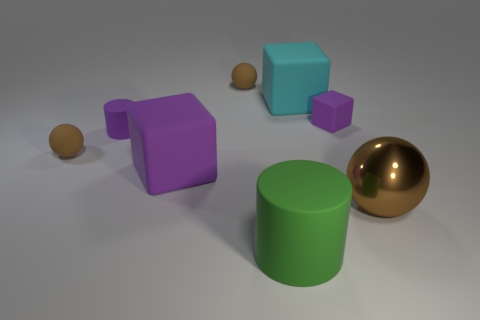Add 1 green things. How many objects exist? 9 Subtract all cylinders. How many objects are left? 6 Subtract 0 purple balls. How many objects are left? 8 Subtract all big spheres. Subtract all big purple blocks. How many objects are left? 6 Add 7 large metal balls. How many large metal balls are left? 8 Add 7 tiny balls. How many tiny balls exist? 9 